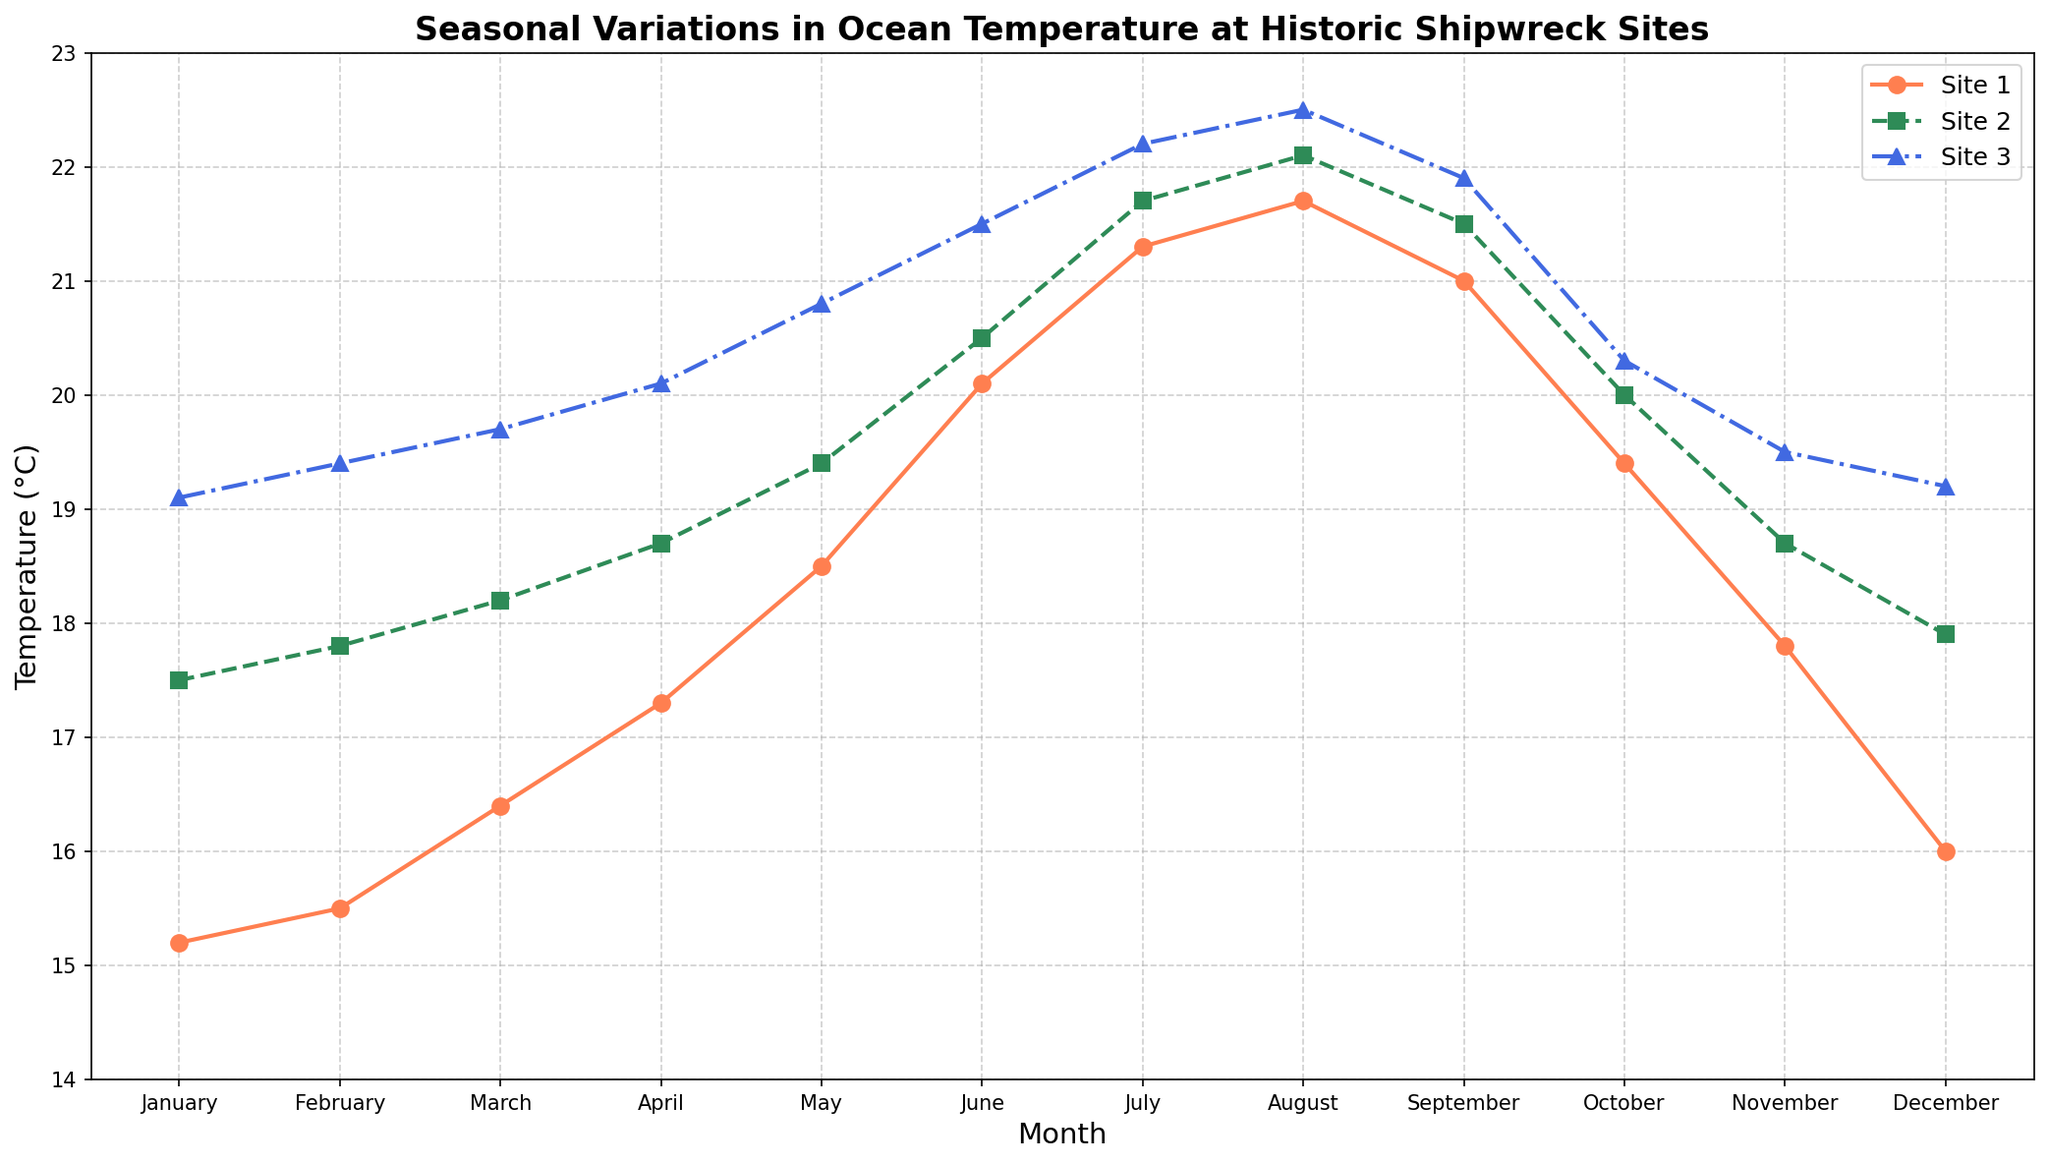What's the highest recorded temperature among the three sites? To find the highest recorded temperature, we look at the peaks of the temperature lines for all three sites. For Site 1, the highest temperature is 21.7°C (August). For Site 2, the highest temperature is 22.1°C (August). For Site 3, the highest temperature is 22.5°C (August). The overall maximum temperature among them is 22.5°C.
Answer: 22.5°C In which month do all three sites have the closest temperatures? We need to compare the temperature differences for all three sites month by month. Closest differences are seen in June when Site 1 is 20.1°C, Site 2 is 20.5°C, and Site 3 is 21.5°C. Thus, the differences between the sites are minimal in June.
Answer: June How does the temperature trend of Site 1 from January to December compare to Site 3? To compare the trends, we observe the overall patterns. Site 1 starts at 15.2°C in January, peaks at 21.7°C in August, and goes back down to 16.0°C in December. Site 3 starts at 19.1°C, peaks at 22.5°C in August, and goes back down to 19.2°C in December. Both sites have similar upward trends peaking in August and then descending.
Answer: Similar upward and downward trend with peak in August What is the average temperature for Site 2 in the summer months (June, July, and August)? To calculate the average, sum the temperatures for June (20.5°C), July (21.7°C), and August (22.1°C) and divide by 3. The total is 64.3°C, so the average is 64.3/3.
Answer: 21.43°C Between which consecutive months does Site 3 experience the largest temperature increase? We subtract the temperature of each month from the temperature of the preceding month for Site 3 and identify the highest increase. The largest temperature increase is between April and May (20.1°C to 20.8°C), which is a difference of 0.7°C.
Answer: April to May Which site shows the least variation in temperature throughout the year? By visually inspecting the range (lowest to highest) of the temperature changes, Site 2 varies from 17.5°C to 22.1°C, a range of 4.6°C. Site 1 ranges from 15.2°C to 21.7°C, a range of 6.5°C. Site 3 ranges from 19.1°C to 22.5°C, a range of 3.4°C. Hence, Site 3 has the least variation.
Answer: Site 3 